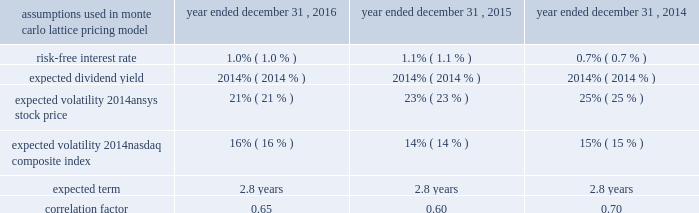Table of contents .
The company issued 35000 , 115485 and 39900 performance-based restricted stock awards during 2016 , 2015 and 2014 , respectively .
Of the cumulative performance-based restricted stock awards issued , defined operating metrics were assigned to 63462 , 51795 and 20667 awards with grant-date fair values of $ 84.61 , $ 86.38 and $ 81.52 during 2016 , 2015 and 2014 , respectively .
The grant-date fair value of the awards is being recorded from the grant date through the conclusion of the measurement period associated with each operating metric based on management's estimates concerning the probability of vesting .
As of december 31 , 2016 , 7625 units of the total 2014 awards granted were earned and will be issued in 2017 .
Total compensation expense associated with the awards recorded for the years ended december 31 , 2016 , 2015 and 2014 was $ 0.4 million , $ 0.4 million and $ 0.1 million , respectively .
In addition , in 2016 , 2015 and 2014 , the company granted restricted stock units of 488622 , 344500 and 364150 , respectively , that will vest over a three- or four-year period with weighted-average grant-date fair values of $ 88.51 , $ 86.34 and $ 82.13 , respectively .
During 2016 and 2015 , 162019 and 85713 shares vested and were released , respectively .
As of december 31 , 2016 , 2015 and 2014 , 838327 , 571462 and 344750 units were outstanding , respectively .
Total compensation expense is being recorded over the service period and was $ 19.1 million , $ 12.5 million and $ 5.8 million for the years ended december 31 , 2016 , 2015 and 2014 , respectively .
In conjunction with a 2015 acquisition , ansys issued 68451 shares of replacement restricted stock with a weighted-average grant-date fair value of $ 90.48 .
Of the $ 6.2 million grant-date fair value , $ 3.5 million , related to partially vested awards , was recorded as non-cash purchase price consideration .
The remaining fair value will be recognized as stock compensation expense through the conclusion of the service period .
During the years ended december 31 , 2016 and 2015 , the company recorded $ 1.2 million and $ 0.6 million , respectively , of stock compensation expense related to these awards .
In conjunction with a 2011 acquisition , the company granted performance-based restricted stock awards .
Vesting was determined based on the achievements of certain revenue and operating income targets of the entity post-acquisition .
Total compensation expense associated with the awards recorded for the year ended december 31 , 2014 was $ 4.7 million .
The company has granted deferred stock awards to non-affiliate independent directors , which are rights to receive shares of common stock upon termination of service as a director .
In 2015 and prior , the deferred stock awards were granted quarterly in arrears and vested immediately upon grant .
Associated with these awards , the company established a non-qualified 409 ( a ) deferred compensation plan with assets held under a rabbi trust to provide directors an opportunity to diversify their vested awards .
During open trading windows and at their elective option , the directors may convert their company shares into a variety of non-company-stock investment options in order to diversify their holdings .
As of december 31 , 2016 , 5000 shares have been diversified and 184099 undiversified deferred stock awards have vested with the underlying shares remaining unissued until the service termination of the respective director owners .
In may 2016 , the company granted 38400 deferred stock awards which will vest in full on the one-year anniversary of the grant .
Total compensation expense associated with the awards recorded for the years ended december 31 , 2016 , 2015 and 2014 was $ 1.9 million , $ 4.0 million and $ 3.5 million , respectively. .
What was the percentage change in the expected volatility 2014nasdaq composite index from 2015 to 2016 16% ( 16 % ) 14% ( 14 % )? 
Computations: ((16 - 14) / 14)
Answer: 0.14286. Table of contents .
The company issued 35000 , 115485 and 39900 performance-based restricted stock awards during 2016 , 2015 and 2014 , respectively .
Of the cumulative performance-based restricted stock awards issued , defined operating metrics were assigned to 63462 , 51795 and 20667 awards with grant-date fair values of $ 84.61 , $ 86.38 and $ 81.52 during 2016 , 2015 and 2014 , respectively .
The grant-date fair value of the awards is being recorded from the grant date through the conclusion of the measurement period associated with each operating metric based on management's estimates concerning the probability of vesting .
As of december 31 , 2016 , 7625 units of the total 2014 awards granted were earned and will be issued in 2017 .
Total compensation expense associated with the awards recorded for the years ended december 31 , 2016 , 2015 and 2014 was $ 0.4 million , $ 0.4 million and $ 0.1 million , respectively .
In addition , in 2016 , 2015 and 2014 , the company granted restricted stock units of 488622 , 344500 and 364150 , respectively , that will vest over a three- or four-year period with weighted-average grant-date fair values of $ 88.51 , $ 86.34 and $ 82.13 , respectively .
During 2016 and 2015 , 162019 and 85713 shares vested and were released , respectively .
As of december 31 , 2016 , 2015 and 2014 , 838327 , 571462 and 344750 units were outstanding , respectively .
Total compensation expense is being recorded over the service period and was $ 19.1 million , $ 12.5 million and $ 5.8 million for the years ended december 31 , 2016 , 2015 and 2014 , respectively .
In conjunction with a 2015 acquisition , ansys issued 68451 shares of replacement restricted stock with a weighted-average grant-date fair value of $ 90.48 .
Of the $ 6.2 million grant-date fair value , $ 3.5 million , related to partially vested awards , was recorded as non-cash purchase price consideration .
The remaining fair value will be recognized as stock compensation expense through the conclusion of the service period .
During the years ended december 31 , 2016 and 2015 , the company recorded $ 1.2 million and $ 0.6 million , respectively , of stock compensation expense related to these awards .
In conjunction with a 2011 acquisition , the company granted performance-based restricted stock awards .
Vesting was determined based on the achievements of certain revenue and operating income targets of the entity post-acquisition .
Total compensation expense associated with the awards recorded for the year ended december 31 , 2014 was $ 4.7 million .
The company has granted deferred stock awards to non-affiliate independent directors , which are rights to receive shares of common stock upon termination of service as a director .
In 2015 and prior , the deferred stock awards were granted quarterly in arrears and vested immediately upon grant .
Associated with these awards , the company established a non-qualified 409 ( a ) deferred compensation plan with assets held under a rabbi trust to provide directors an opportunity to diversify their vested awards .
During open trading windows and at their elective option , the directors may convert their company shares into a variety of non-company-stock investment options in order to diversify their holdings .
As of december 31 , 2016 , 5000 shares have been diversified and 184099 undiversified deferred stock awards have vested with the underlying shares remaining unissued until the service termination of the respective director owners .
In may 2016 , the company granted 38400 deferred stock awards which will vest in full on the one-year anniversary of the grant .
Total compensation expense associated with the awards recorded for the years ended december 31 , 2016 , 2015 and 2014 was $ 1.9 million , $ 4.0 million and $ 3.5 million , respectively. .
What was the average total compensation expense associated with the awards from 2014 to 2016 in millions? 
Computations: (((1.9 + 4.0) + 3.5) / 3)
Answer: 3.13333. 